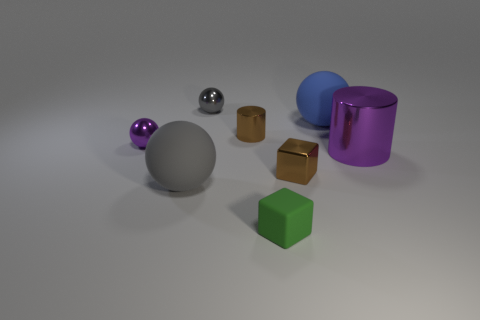Which objects in the image appear to have a reflective surface? The objects with reflective surfaces in the image are the metallic silver sphere, the smaller golden cubes, and the purple cylinder. These surfaces reflect the light and environment, giving them a shinier appearance compared to the other objects. 